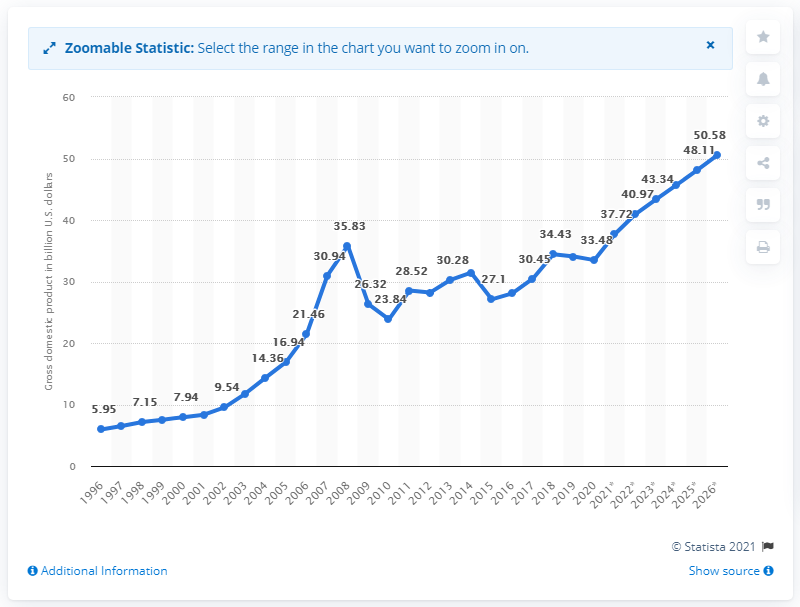List a handful of essential elements in this visual. In 2020, the gross domestic product of Latvia was approximately 33.48 billion dollars. 